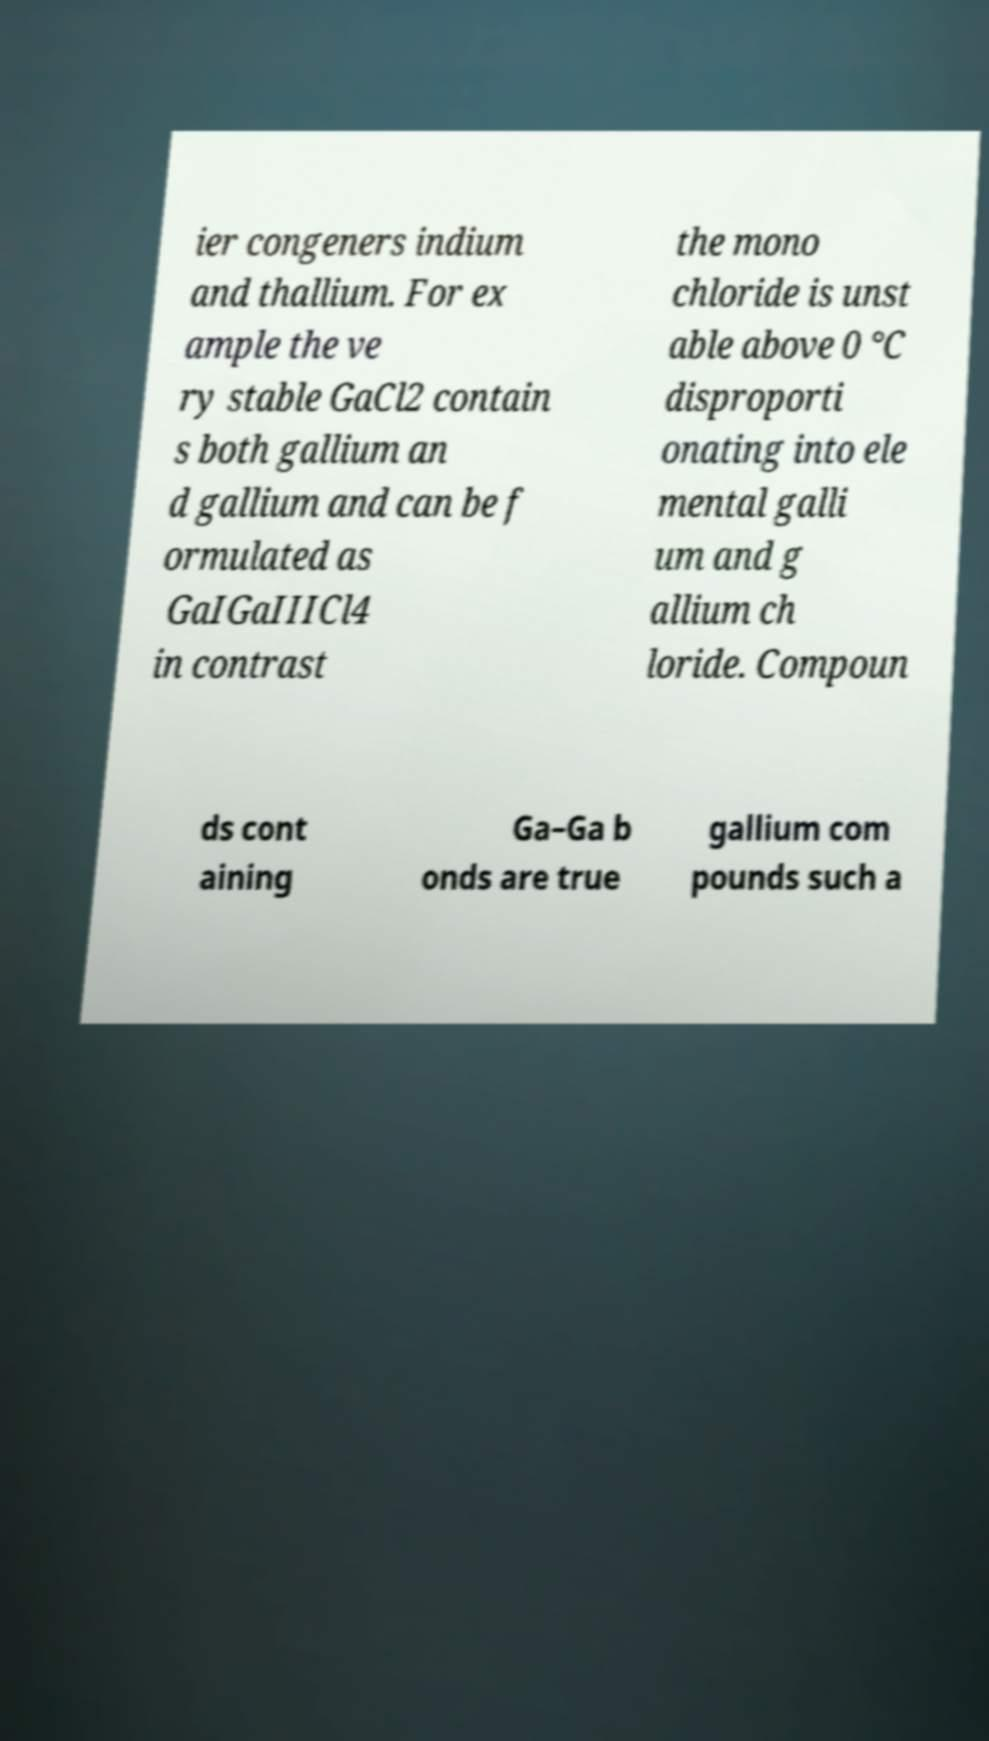Can you read and provide the text displayed in the image?This photo seems to have some interesting text. Can you extract and type it out for me? ier congeners indium and thallium. For ex ample the ve ry stable GaCl2 contain s both gallium an d gallium and can be f ormulated as GaIGaIIICl4 in contrast the mono chloride is unst able above 0 °C disproporti onating into ele mental galli um and g allium ch loride. Compoun ds cont aining Ga–Ga b onds are true gallium com pounds such a 